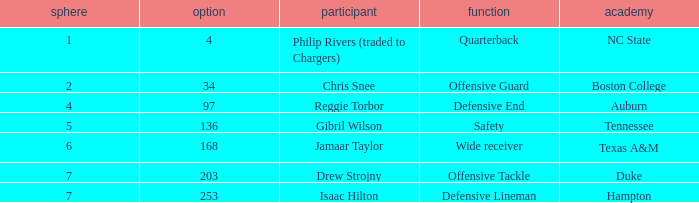Which Selection has a Player of jamaar taylor, and a Round larger than 6? None. Could you parse the entire table? {'header': ['sphere', 'option', 'participant', 'function', 'academy'], 'rows': [['1', '4', 'Philip Rivers (traded to Chargers)', 'Quarterback', 'NC State'], ['2', '34', 'Chris Snee', 'Offensive Guard', 'Boston College'], ['4', '97', 'Reggie Torbor', 'Defensive End', 'Auburn'], ['5', '136', 'Gibril Wilson', 'Safety', 'Tennessee'], ['6', '168', 'Jamaar Taylor', 'Wide receiver', 'Texas A&M'], ['7', '203', 'Drew Strojny', 'Offensive Tackle', 'Duke'], ['7', '253', 'Isaac Hilton', 'Defensive Lineman', 'Hampton']]} 